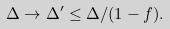Convert formula to latex. <formula><loc_0><loc_0><loc_500><loc_500>\Delta \to \Delta ^ { \prime } \leq \Delta / ( 1 - f ) .</formula> 